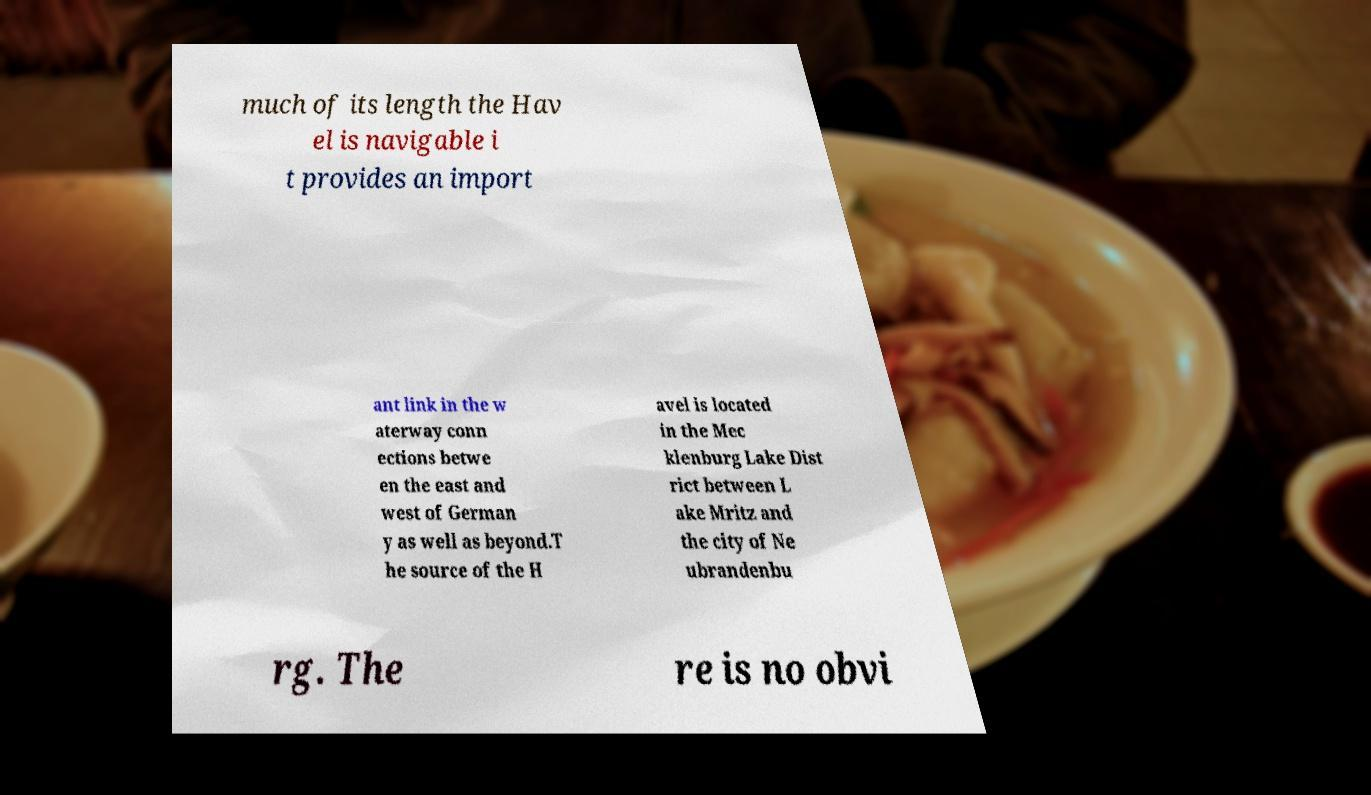Can you accurately transcribe the text from the provided image for me? much of its length the Hav el is navigable i t provides an import ant link in the w aterway conn ections betwe en the east and west of German y as well as beyond.T he source of the H avel is located in the Mec klenburg Lake Dist rict between L ake Mritz and the city of Ne ubrandenbu rg. The re is no obvi 